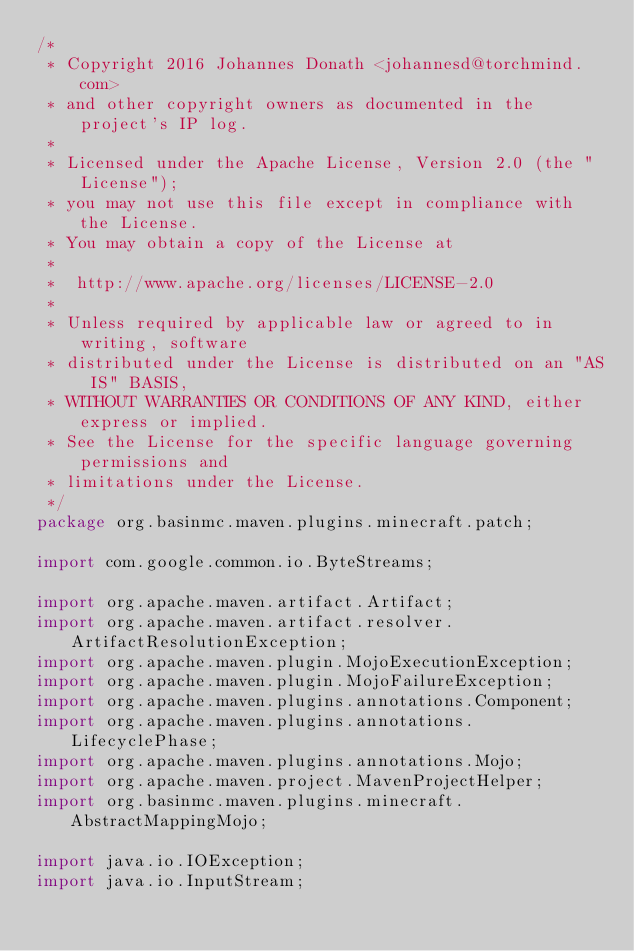<code> <loc_0><loc_0><loc_500><loc_500><_Java_>/*
 * Copyright 2016 Johannes Donath <johannesd@torchmind.com>
 * and other copyright owners as documented in the project's IP log.
 *
 * Licensed under the Apache License, Version 2.0 (the "License");
 * you may not use this file except in compliance with the License.
 * You may obtain a copy of the License at
 *
 * 	http://www.apache.org/licenses/LICENSE-2.0
 *
 * Unless required by applicable law or agreed to in writing, software
 * distributed under the License is distributed on an "AS IS" BASIS,
 * WITHOUT WARRANTIES OR CONDITIONS OF ANY KIND, either express or implied.
 * See the License for the specific language governing permissions and
 * limitations under the License.
 */
package org.basinmc.maven.plugins.minecraft.patch;

import com.google.common.io.ByteStreams;

import org.apache.maven.artifact.Artifact;
import org.apache.maven.artifact.resolver.ArtifactResolutionException;
import org.apache.maven.plugin.MojoExecutionException;
import org.apache.maven.plugin.MojoFailureException;
import org.apache.maven.plugins.annotations.Component;
import org.apache.maven.plugins.annotations.LifecyclePhase;
import org.apache.maven.plugins.annotations.Mojo;
import org.apache.maven.project.MavenProjectHelper;
import org.basinmc.maven.plugins.minecraft.AbstractMappingMojo;

import java.io.IOException;
import java.io.InputStream;</code> 